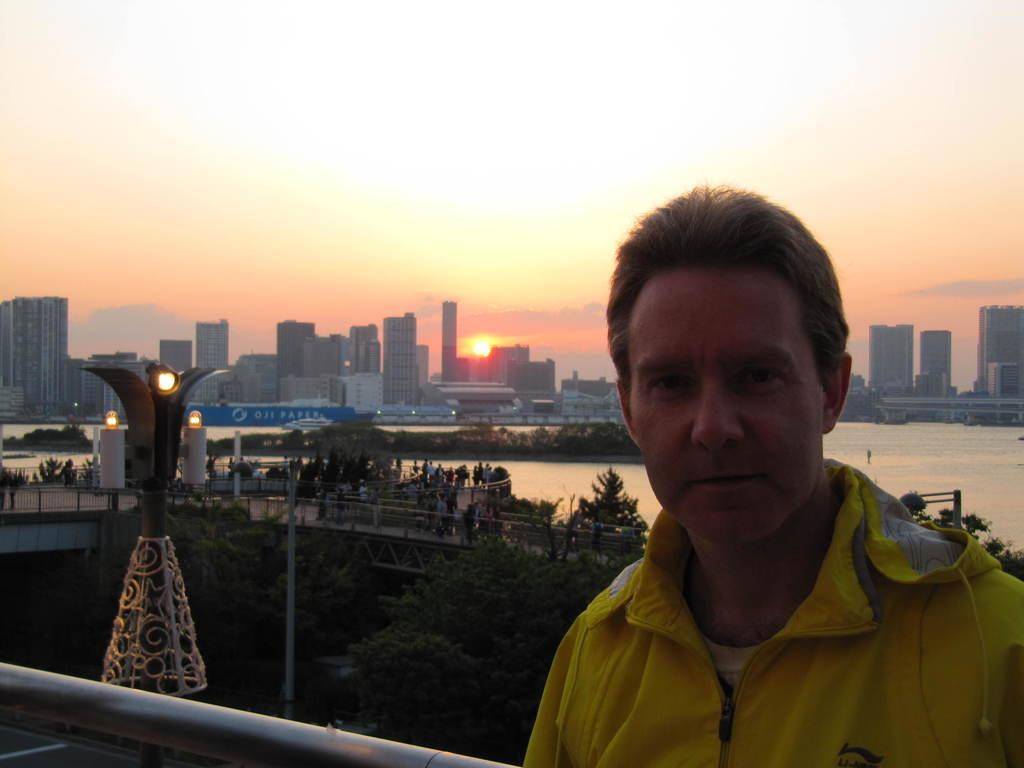What type of structures can be seen in the image? There are buildings in the image. What other natural elements are present in the image? There are trees and water visible in the image. Can you describe the lighting in the image? There is a tower light in the image. What is the weather like in the image? The sky has clouds and the sun is visible, suggesting a partly cloudy day. Is there anyone in the image? Yes, there is a man standing in the image. How many weeks has the man been on his journey in the image? There is no indication of a journey or any time frame in the image, so it is not possible to determine the number of weeks. What type of game is being played in the image? There is no game or any indication of gameplay in the image. 